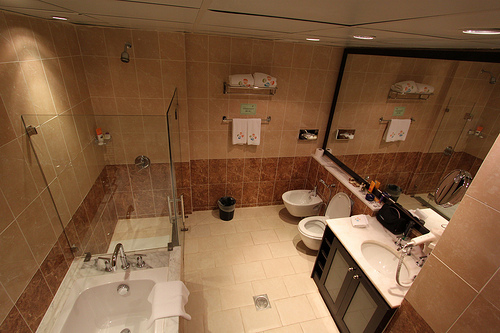How many sinks are in the bathroom? There is one sink in the bathroom, situated on the vanity which is complemented by a large mirror above it, providing a spacious area for personal grooming. 